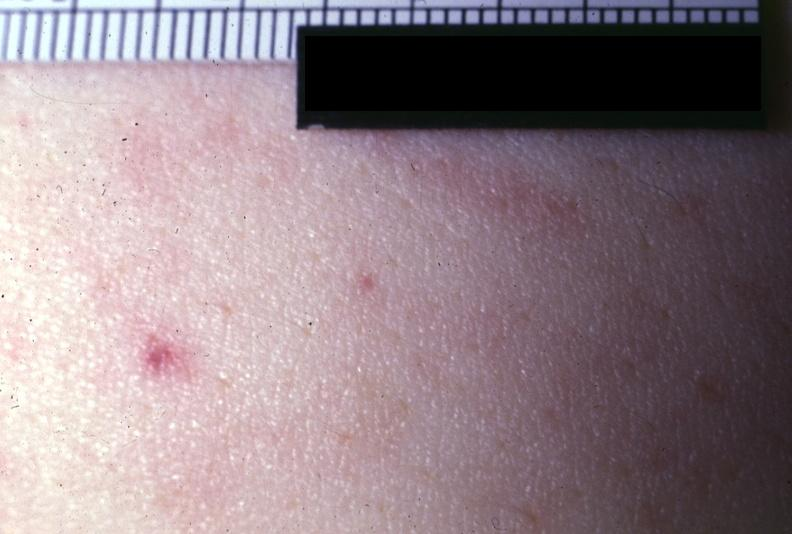what is present?
Answer the question using a single word or phrase. Petechiae 